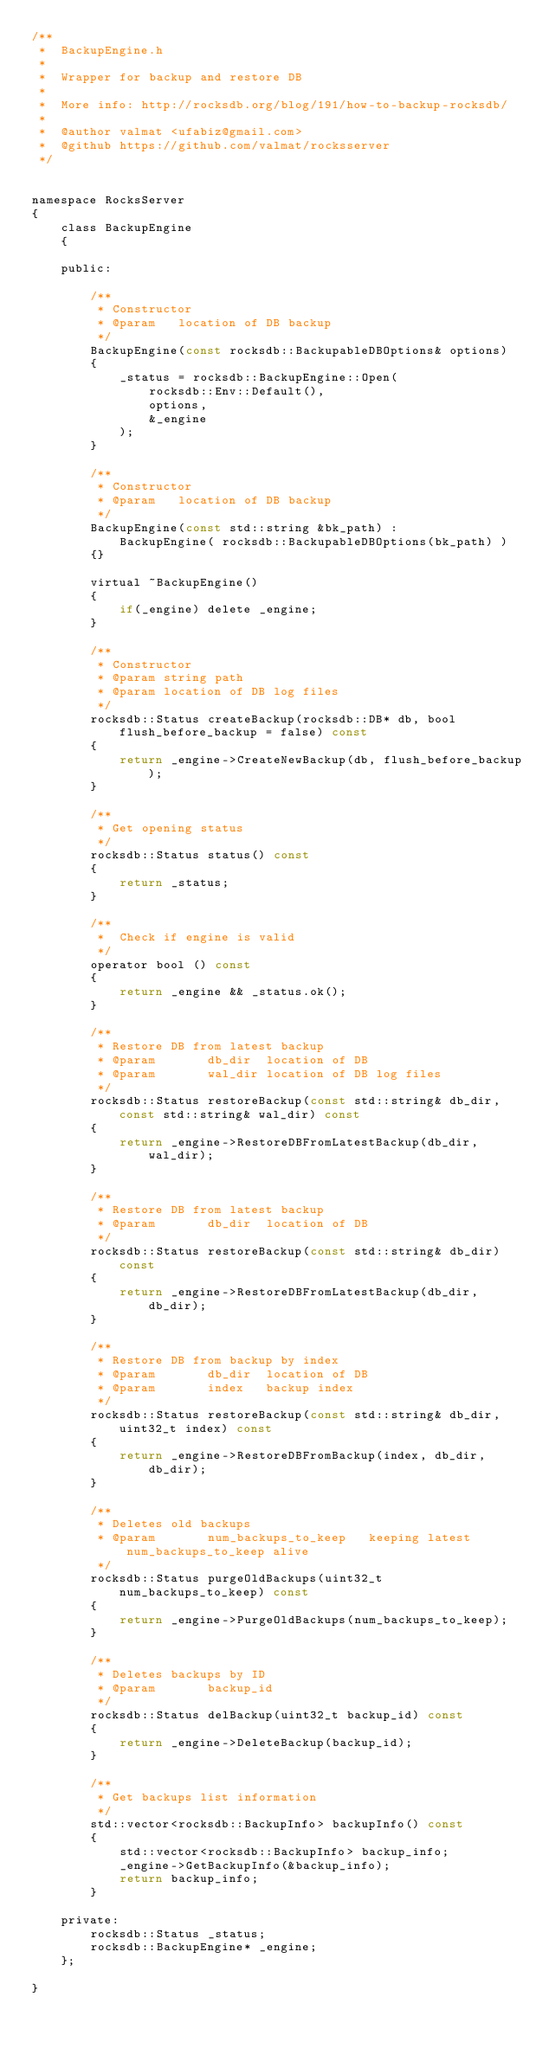Convert code to text. <code><loc_0><loc_0><loc_500><loc_500><_C_>/**
 *  BackupEngine.h
 *
 *  Wrapper for backup and restore DB
 *
 *  More info: http://rocksdb.org/blog/191/how-to-backup-rocksdb/
 *
 *  @author valmat <ufabiz@gmail.com>
 *  @github https://github.com/valmat/rocksserver
 */


namespace RocksServer 
{
    class BackupEngine
    {
    
    public:
        
        /**
         * Constructor
         * @param   location of DB backup
         */
        BackupEngine(const rocksdb::BackupableDBOptions& options)
        {
            _status = rocksdb::BackupEngine::Open(
                rocksdb::Env::Default(),
                options,
                &_engine
            );
        }

        /**
         * Constructor
         * @param   location of DB backup
         */
        BackupEngine(const std::string &bk_path) :
            BackupEngine( rocksdb::BackupableDBOptions(bk_path) )
        {}

        virtual ~BackupEngine()
        {
            if(_engine) delete _engine;
        }

        /**
         * Constructor
         * @param string path
         * @param location of DB log files
         */
        rocksdb::Status createBackup(rocksdb::DB* db, bool flush_before_backup = false) const
        {
            return _engine->CreateNewBackup(db, flush_before_backup);
        }

        /**
         * Get opening status
         */
        rocksdb::Status status() const
        {
            return _status;
        }

        /**
         *  Check if engine is valid
         */
        operator bool () const
        {
            return _engine && _status.ok();
        }

        /**
         * Restore DB from latest backup
         * @param       db_dir  location of DB
         * @param       wal_dir location of DB log files
         */
        rocksdb::Status restoreBackup(const std::string& db_dir, const std::string& wal_dir) const
        {
            return _engine->RestoreDBFromLatestBackup(db_dir, wal_dir);
        }

        /**
         * Restore DB from latest backup
         * @param       db_dir  location of DB
         */
        rocksdb::Status restoreBackup(const std::string& db_dir) const
        {
            return _engine->RestoreDBFromLatestBackup(db_dir, db_dir);
        }

        /**
         * Restore DB from backup by index
         * @param       db_dir  location of DB
         * @param       index   backup index
         */
        rocksdb::Status restoreBackup(const std::string& db_dir, uint32_t index) const
        {
            return _engine->RestoreDBFromBackup(index, db_dir, db_dir);
        }

        /**
         * Deletes old backups
         * @param       num_backups_to_keep   keeping latest num_backups_to_keep alive
         */
        rocksdb::Status purgeOldBackups(uint32_t num_backups_to_keep) const
        {
            return _engine->PurgeOldBackups(num_backups_to_keep);
        }

        /**
         * Deletes backups by ID
         * @param       backup_id
         */
        rocksdb::Status delBackup(uint32_t backup_id) const
        {
            return _engine->DeleteBackup(backup_id);
        }

        /**
         * Get backups list information
         */
        std::vector<rocksdb::BackupInfo> backupInfo() const
        {
            std::vector<rocksdb::BackupInfo> backup_info;
            _engine->GetBackupInfo(&backup_info);
            return backup_info;
        }
        
    private:
        rocksdb::Status _status;
        rocksdb::BackupEngine* _engine;
    };

}</code> 